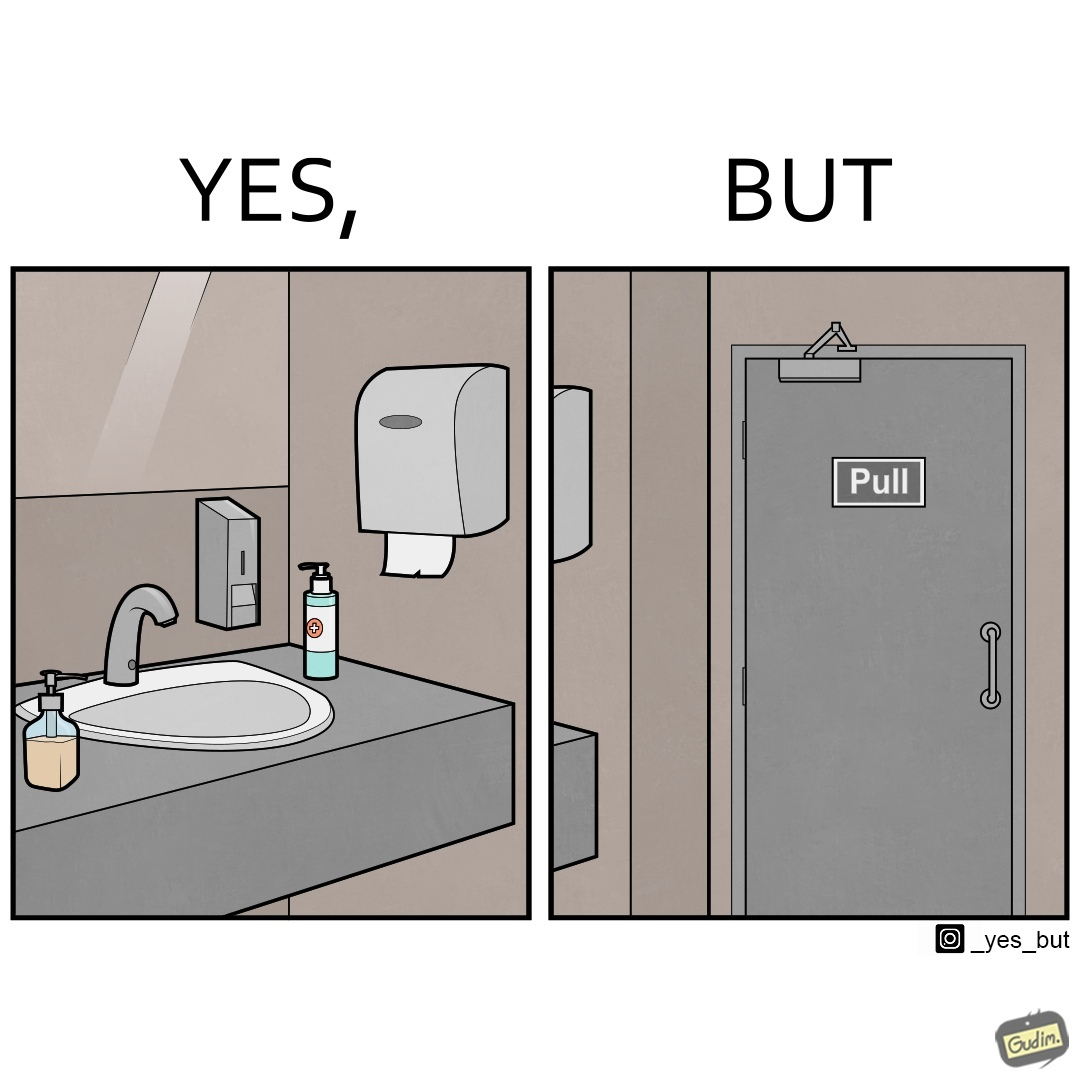Describe the satirical element in this image. The image is ironic, because in the first image in the bathroom there are so many things to clean hands around the basin but in the same bathroom people have to open the doors by hand which can easily spread the germs or bacteria even after times of hand cleaning as there is no way to open it without hands 